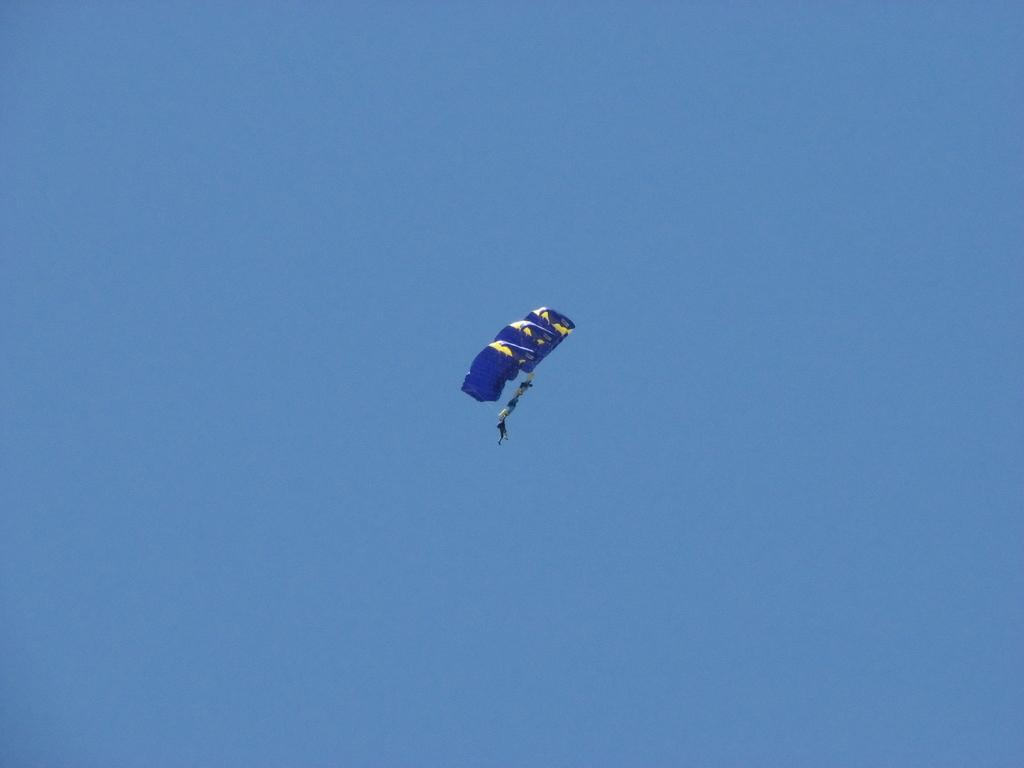What objects are visible in the image related to skydiving? There are parachutes in the image. Can you describe the people in the image? There is a group of people in the air. What type of rifle can be seen in the hands of the girls in the image? There are no girls or rifles present in the image. 